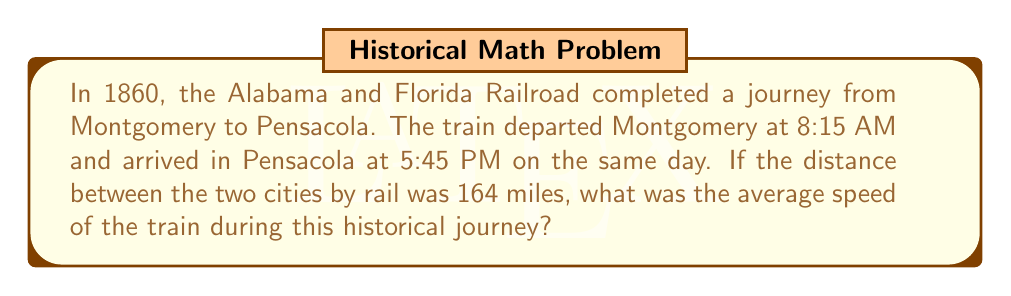Can you solve this math problem? To calculate the average speed of the train, we need to follow these steps:

1. Calculate the total time of the journey:
   Departure time: 8:15 AM
   Arrival time: 5:45 PM
   
   Total time = 5:45 PM - 8:15 AM = 9 hours and 30 minutes = 9.5 hours

2. Convert the distance to the appropriate unit:
   The distance is already given in miles, which is commonly used for speed calculations.

3. Apply the average speed formula:
   Average speed = Total distance / Total time
   
   $$ \text{Average speed} = \frac{\text{Total distance}}{\text{Total time}} $$

4. Substitute the values:
   $$ \text{Average speed} = \frac{164 \text{ miles}}{9.5 \text{ hours}} $$

5. Perform the division:
   $$ \text{Average speed} = 17.26315789... \text{ miles per hour} $$

6. Round to a reasonable number of decimal places:
   Average speed ≈ 17.3 miles per hour

Therefore, the average speed of the train during this historical journey was approximately 17.3 miles per hour.
Answer: 17.3 miles per hour 